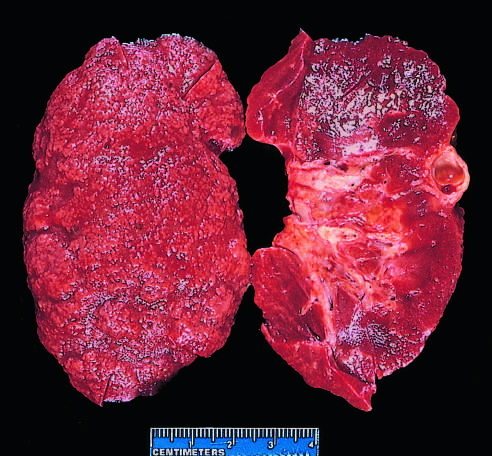what do additional features include?
Answer the question using a single word or phrase. Irregular depressions and an incidental cortical cyst far 